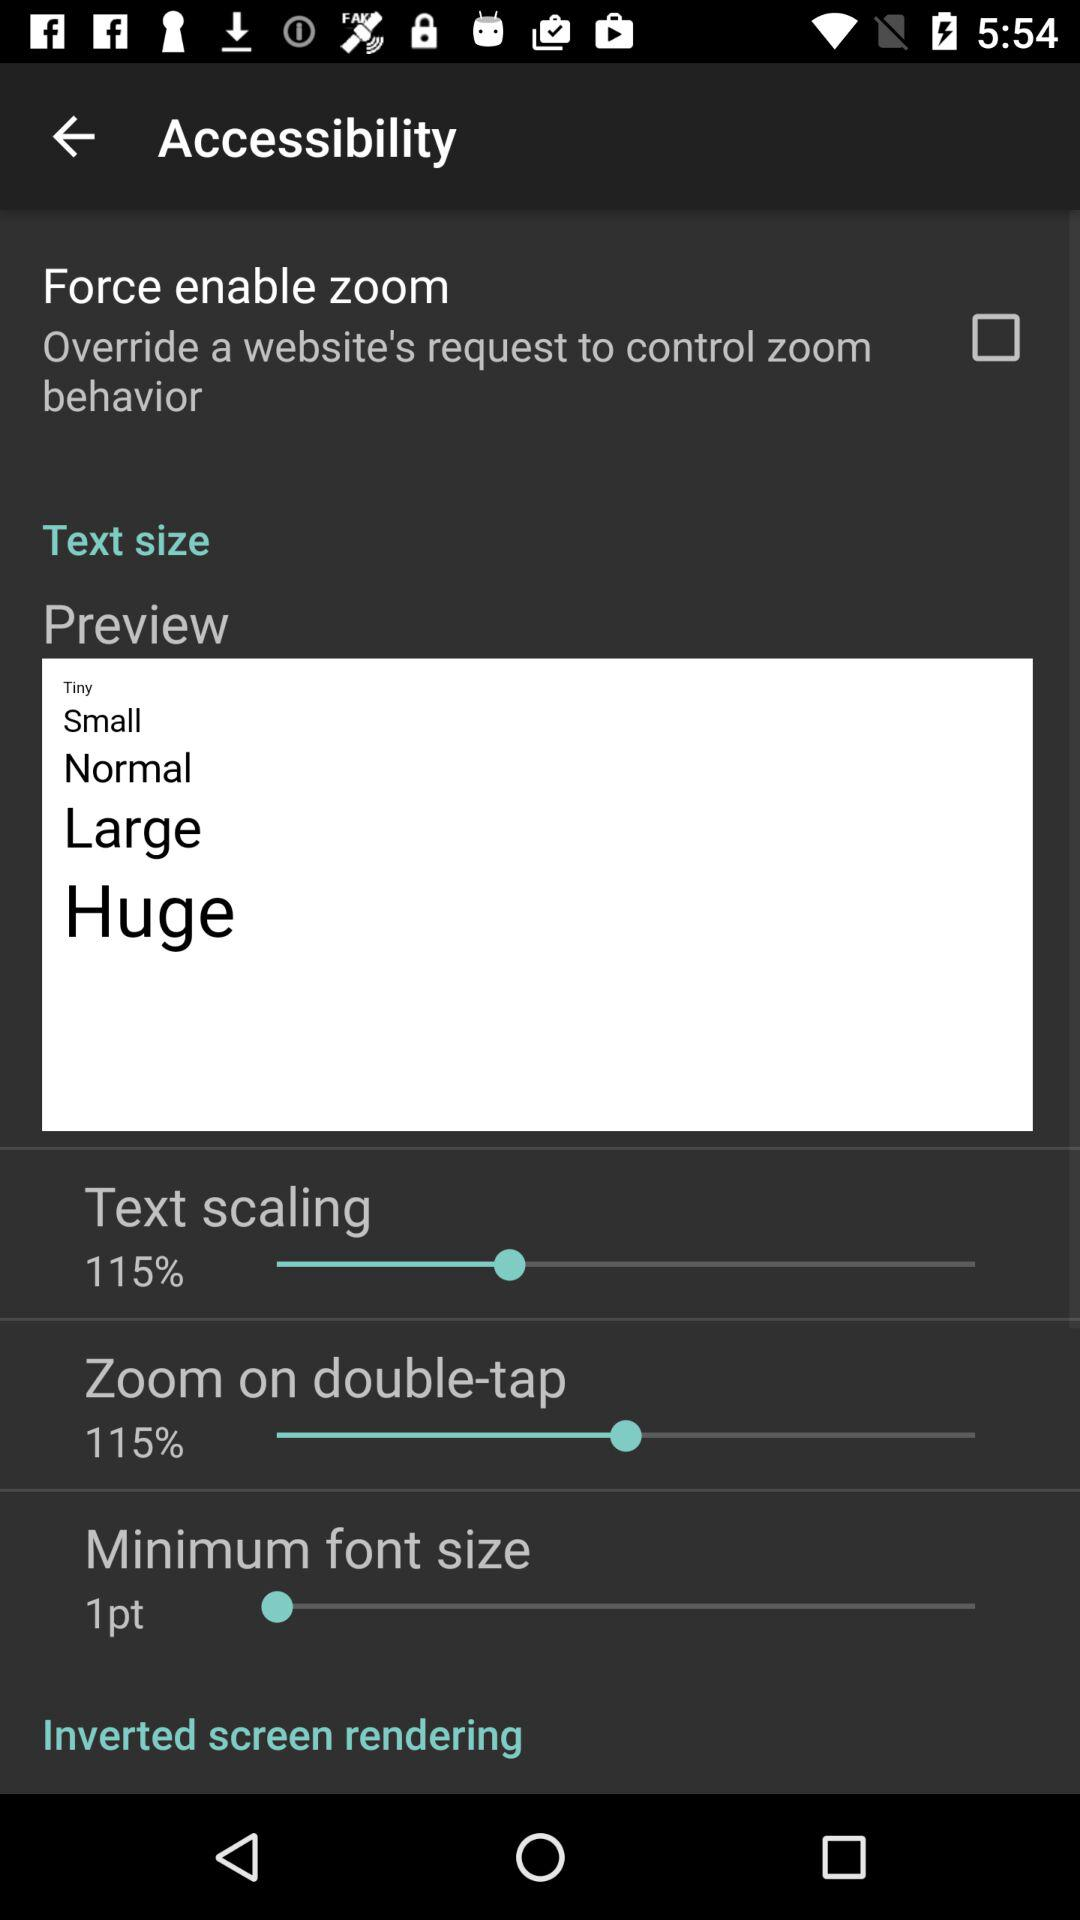What is the percentage of "Text scaling"? The percentage of "Text scaling" is 115. 